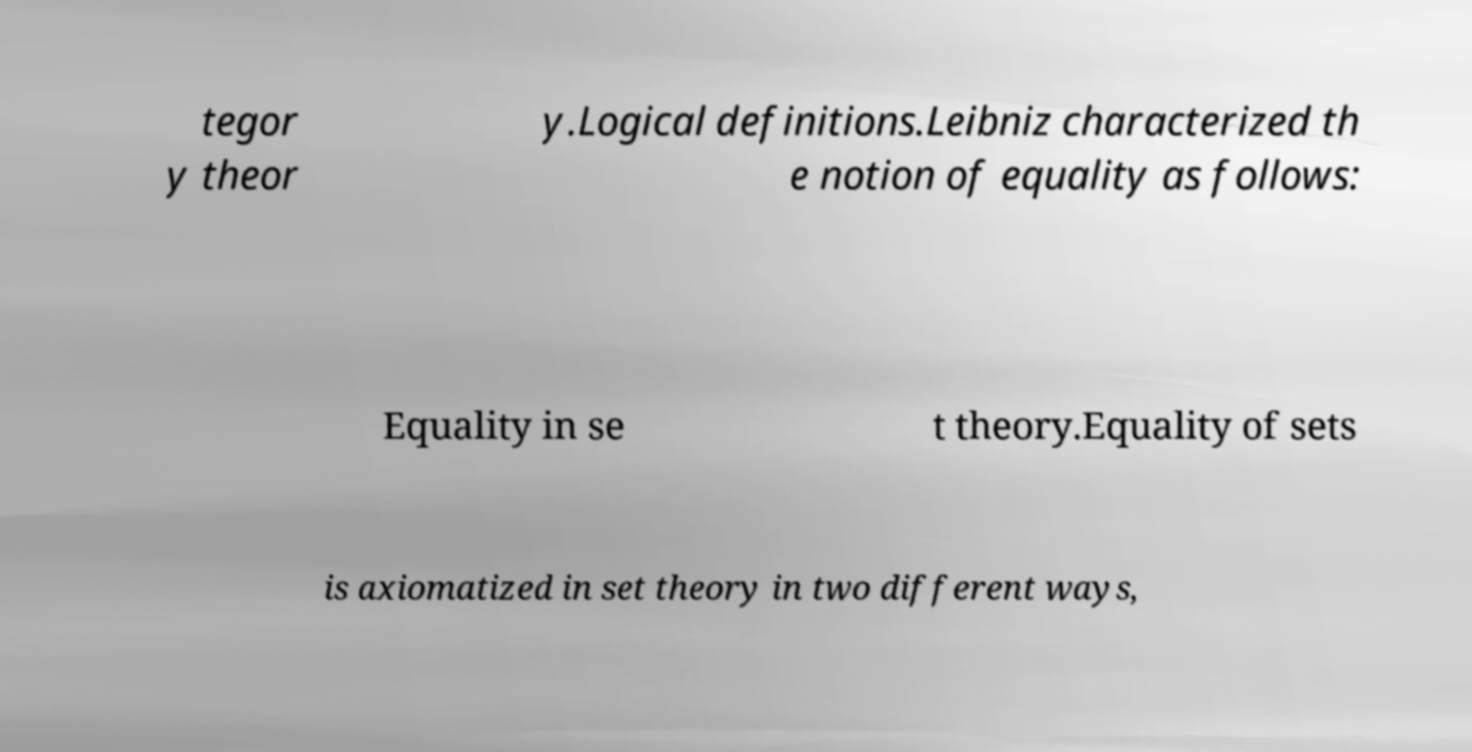Could you extract and type out the text from this image? tegor y theor y.Logical definitions.Leibniz characterized th e notion of equality as follows: Equality in se t theory.Equality of sets is axiomatized in set theory in two different ways, 